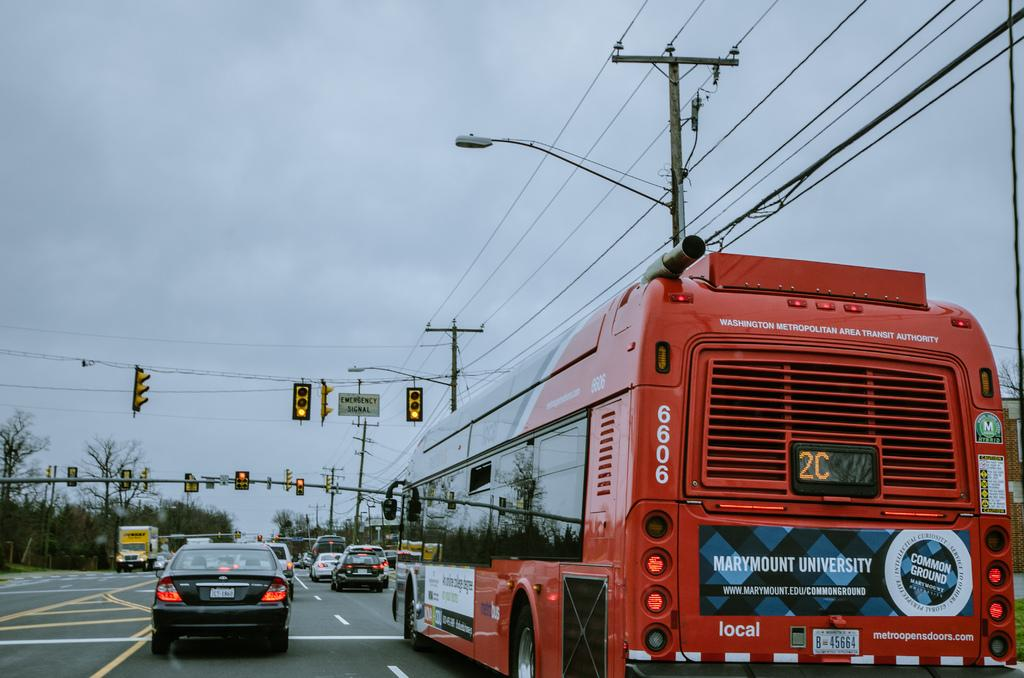What can be seen on the road in the image? There are vehicles on the road in the image. What structures are present near the road in the image? There are traffic signal poles in the image. What are the traffic signal poles equipped with? There are street lights on the poles in the image. What else is visible in the image besides the vehicles and poles? Wires are visible in the image. What can be seen in the background of the image? There are trees and clouds in the sky in the background of the image. What type of cough does the grandmother have in the image? There is no grandmother or cough present in the image. How does the earth interact with the vehicles in the image? The image does not depict any interaction between the vehicles and the earth; it simply shows vehicles on a road. 